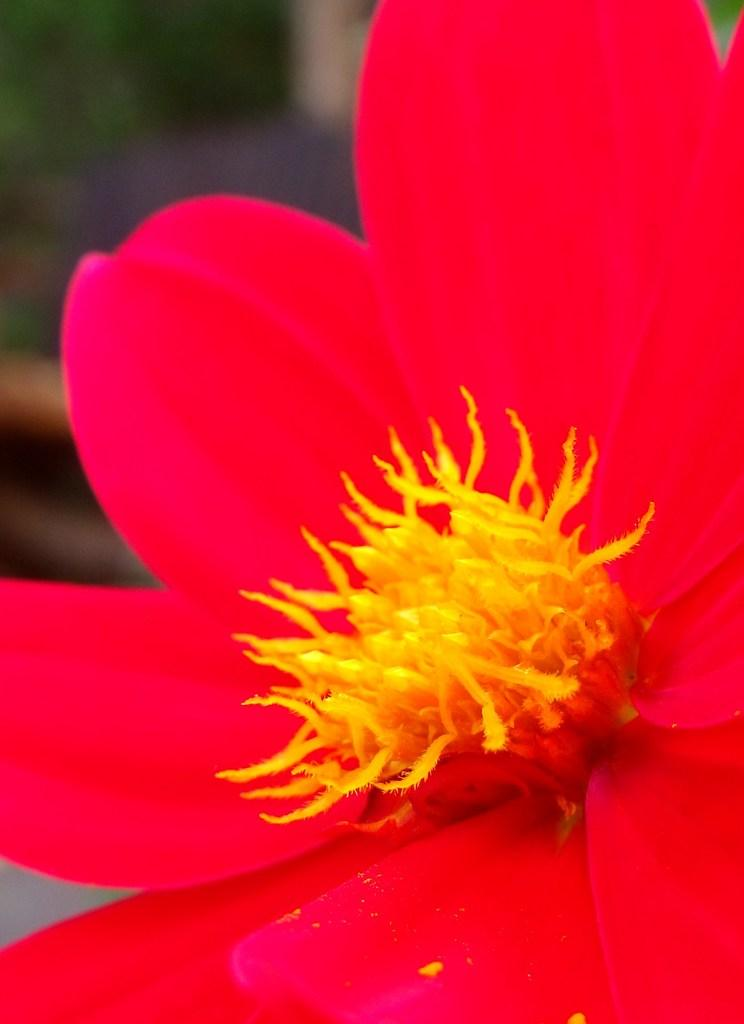What type of flower is present in the image? There is a pink color flower in the image. Can you describe the background of the image? The background of the image is blurred. How many lizards can be seen crawling on the flower in the image? There are no lizards present in the image; it features a pink color flower with a blurred background. 